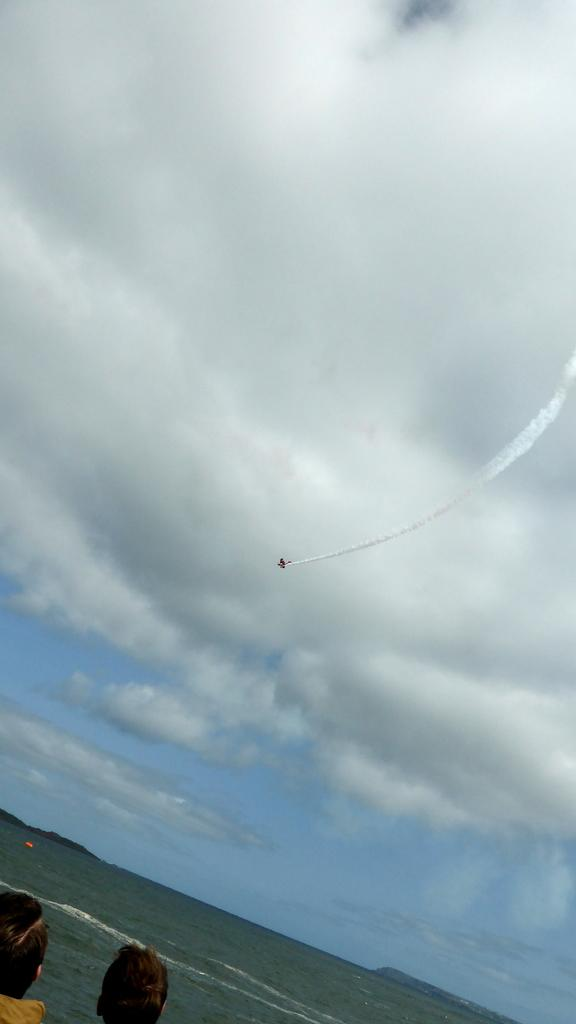What is the main subject of the image? The main subject of the image is an aeroplane. What is the aeroplane doing in the image? The aeroplane is flying in the sky. Can you describe the people at the bottom of the image? There are people at the bottom of the image, but their specific actions or characteristics are not mentioned in the facts. What else can be seen in the image besides the aeroplane? There is water visible in the image, and the sky is visible in the background. What type of toy can be seen in the hands of the grandmother in the image? There is no grandmother or toy present in the image. 